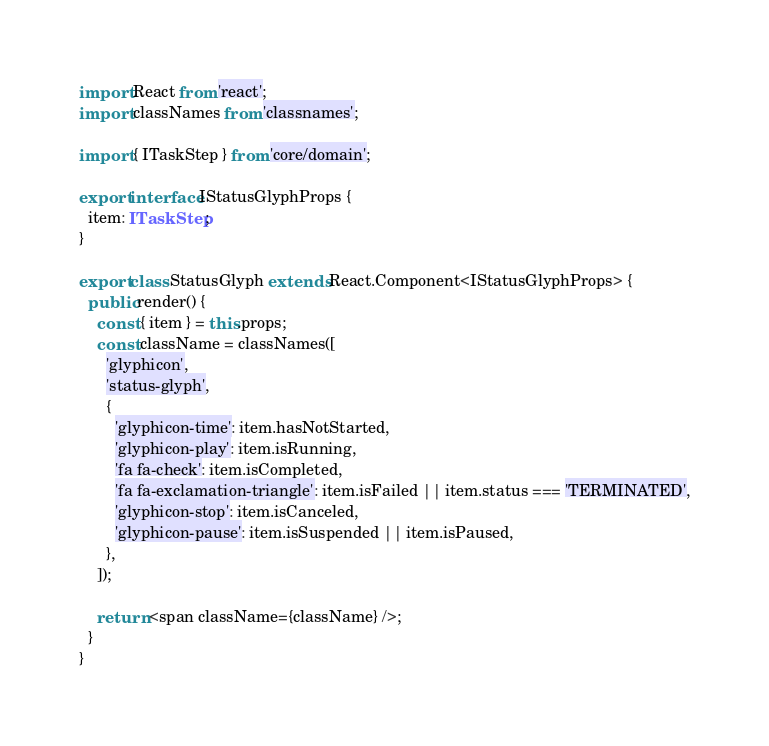<code> <loc_0><loc_0><loc_500><loc_500><_TypeScript_>import React from 'react';
import classNames from 'classnames';

import { ITaskStep } from 'core/domain';

export interface IStatusGlyphProps {
  item: ITaskStep;
}

export class StatusGlyph extends React.Component<IStatusGlyphProps> {
  public render() {
    const { item } = this.props;
    const className = classNames([
      'glyphicon',
      'status-glyph',
      {
        'glyphicon-time': item.hasNotStarted,
        'glyphicon-play': item.isRunning,
        'fa fa-check': item.isCompleted,
        'fa fa-exclamation-triangle': item.isFailed || item.status === 'TERMINATED',
        'glyphicon-stop': item.isCanceled,
        'glyphicon-pause': item.isSuspended || item.isPaused,
      },
    ]);

    return <span className={className} />;
  }
}
</code> 